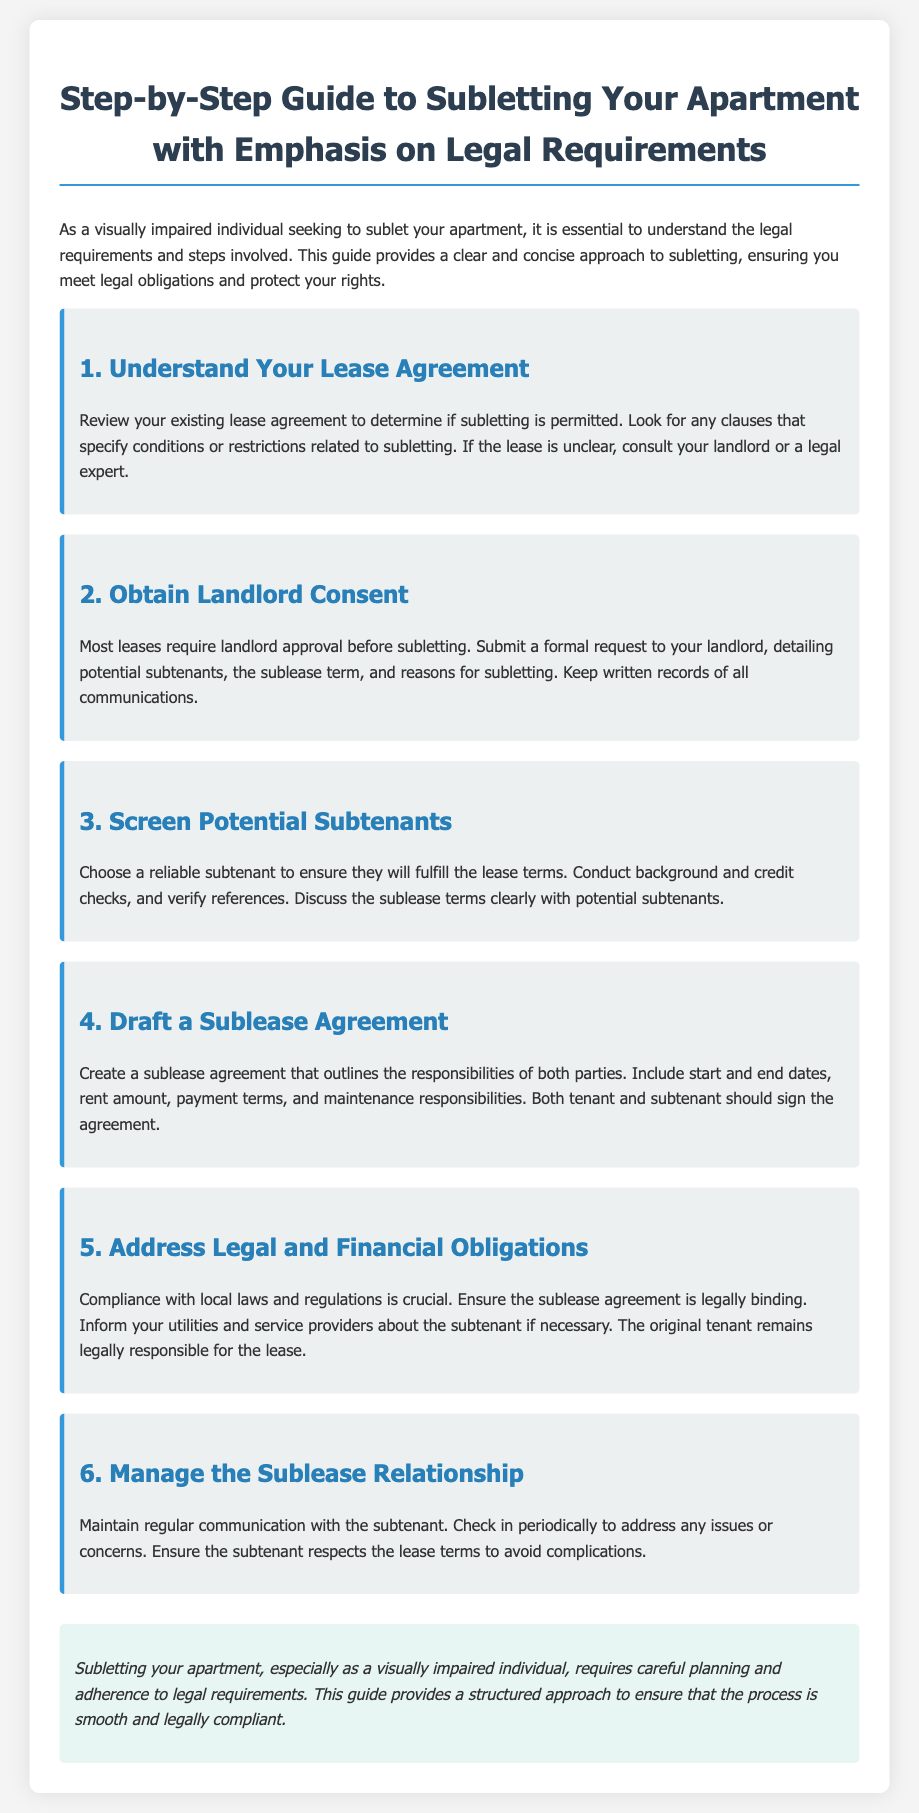What is the title of the document? The title is provided at the beginning of the document and indicates its main subject.
Answer: Step-by-Step Guide to Subletting Your Apartment with Emphasis on Legal Requirements What is the first step in the subletting process? The first step is outlined in the first section of the document, specifying what to check in the lease agreement.
Answer: Understand Your Lease Agreement What should you do if your lease is unclear about subletting? This question relates to the guidance provided in the first section of the document regarding lease clarity.
Answer: Consult your landlord or a legal expert What is required before subletting according to most leases? The document specifically mentions a necessity that is commonly required by most lease agreements.
Answer: Landlord approval What should be included in a sublease agreement? This question addresses important elements that must be part of the sublease agreement as mentioned in the document.
Answer: Responsibilities of both parties Who remains legally responsible for the lease? This question refers to the aspect of legal obligations highlighted in the fifth section of the document.
Answer: The original tenant How often should you communicate with the subtenant? The document suggests a frequency of contact to ensure effective management of the sublease.
Answer: Regularly What color is the section heading for “5. Address Legal and Financial Obligations”? This question checks the specific visual styling employed in the document for key sections.
Answer: Blue What should you do if there are issues with the subtenant? The document advises on a particular approach to managing sublease relationships and addressing concerns.
Answer: Check in periodically 